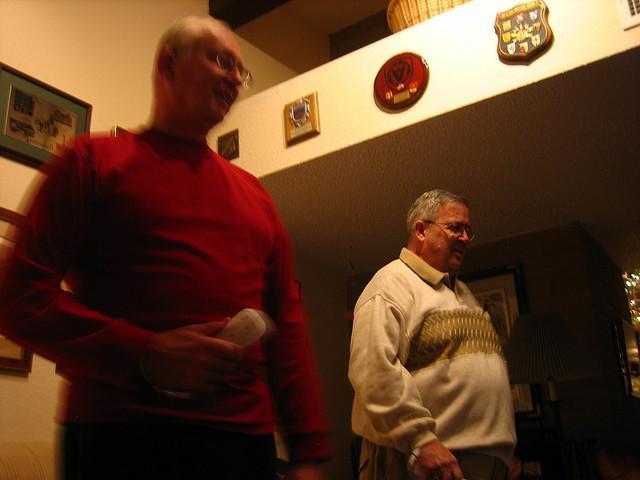How many people are there?
Give a very brief answer. 2. 